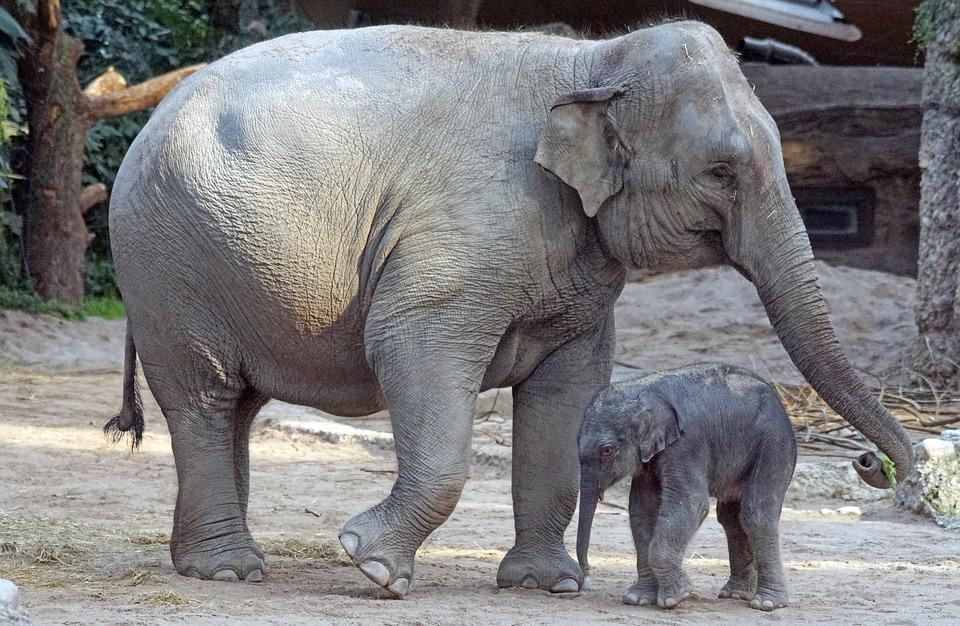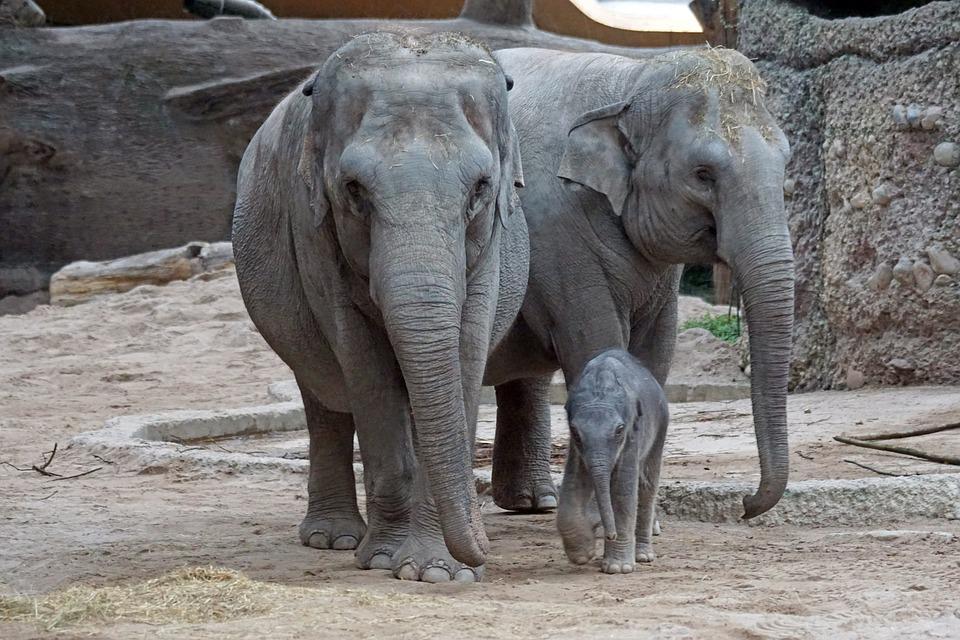The first image is the image on the left, the second image is the image on the right. For the images displayed, is the sentence "There are more animals on the left than the right." factually correct? Answer yes or no. No. 